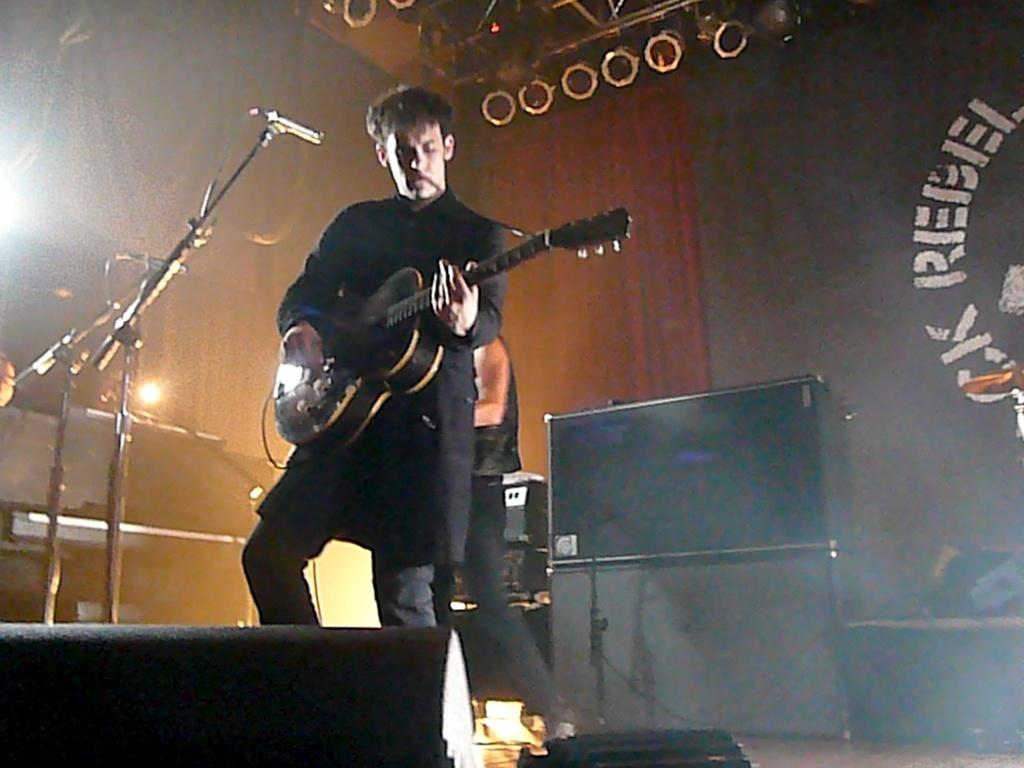Who is present in the image? There is a man in the image. What is the man doing in the image? The man is standing in the image. What object is the man holding in his hands? The man is holding a guitar in his hands. What equipment is present for amplifying sound in the image? There is a microphone and a microphone stand in the image. What can be seen in the image that might indicate a performance or event? There are lights visible in the image. What type of wool is being used to write on the microphone stand in the image? There is no wool present in the image, and the microphone stand is not being used for writing. 